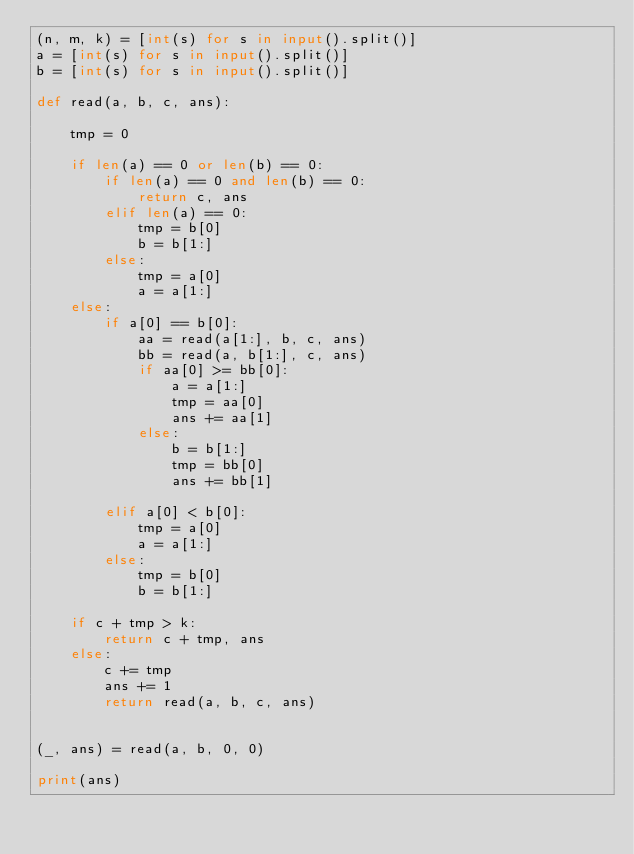Convert code to text. <code><loc_0><loc_0><loc_500><loc_500><_Python_>(n, m, k) = [int(s) for s in input().split()]
a = [int(s) for s in input().split()]
b = [int(s) for s in input().split()]

def read(a, b, c, ans):

    tmp = 0

    if len(a) == 0 or len(b) == 0:
        if len(a) == 0 and len(b) == 0:
            return c, ans
        elif len(a) == 0:
            tmp = b[0]
            b = b[1:]
        else:
            tmp = a[0]
            a = a[1:]
    else:
        if a[0] == b[0]:
            aa = read(a[1:], b, c, ans)
            bb = read(a, b[1:], c, ans)
            if aa[0] >= bb[0]:
                a = a[1:]
                tmp = aa[0]
                ans += aa[1]
            else:
                b = b[1:]
                tmp = bb[0]
                ans += bb[1]

        elif a[0] < b[0]:
            tmp = a[0]
            a = a[1:]
        else:
            tmp = b[0]
            b = b[1:]

    if c + tmp > k:
        return c + tmp, ans
    else:
        c += tmp
        ans += 1
        return read(a, b, c, ans)


(_, ans) = read(a, b, 0, 0)

print(ans)</code> 